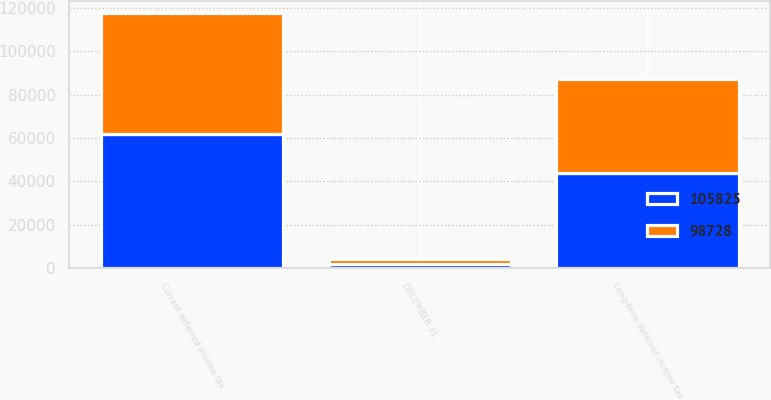Convert chart. <chart><loc_0><loc_0><loc_500><loc_500><stacked_bar_chart><ecel><fcel>DECEMBER 31<fcel>Current deferred income tax<fcel>Long-term deferred income tax<nl><fcel>105825<fcel>2008<fcel>61955<fcel>43870<nl><fcel>98728<fcel>2007<fcel>55522<fcel>43206<nl></chart> 